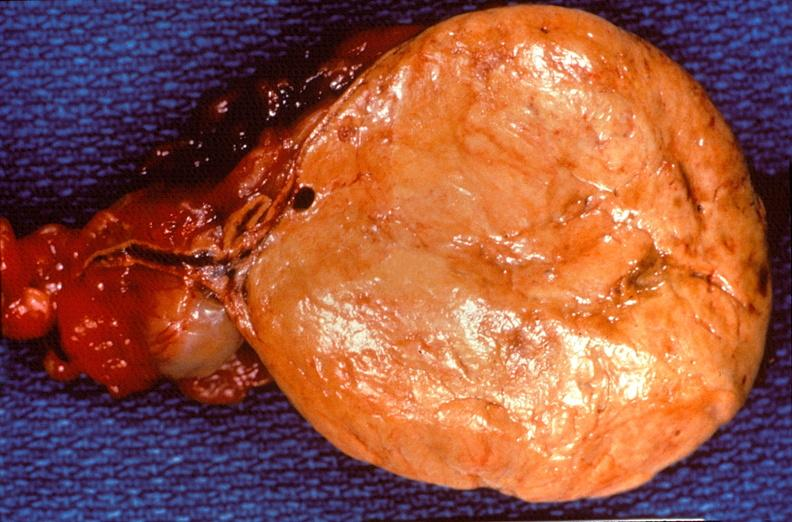does sacrococcygeal teratoma show pituitary, chromaphobe adenoma?
Answer the question using a single word or phrase. No 